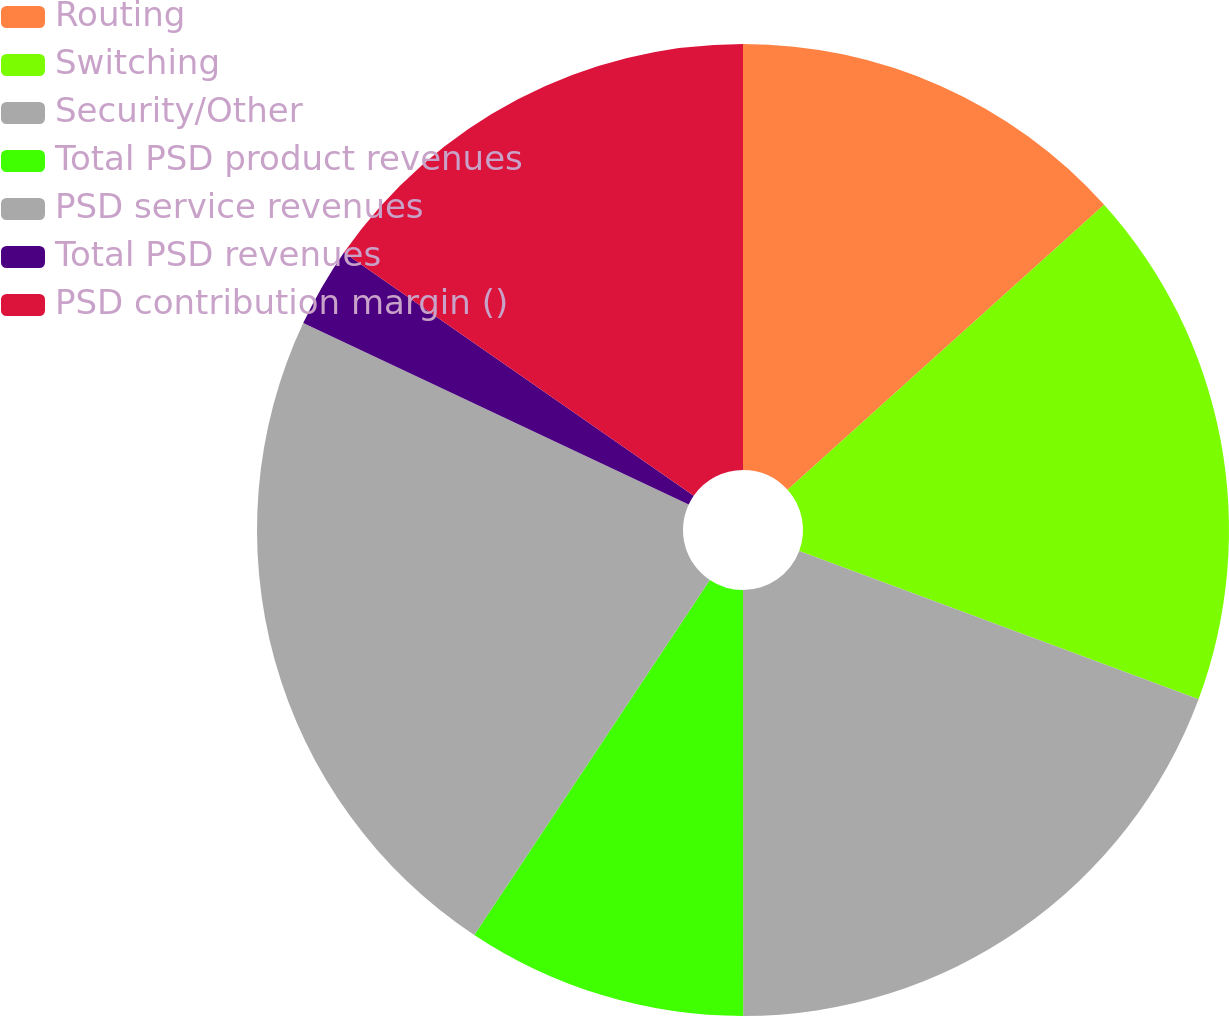Convert chart to OTSL. <chart><loc_0><loc_0><loc_500><loc_500><pie_chart><fcel>Routing<fcel>Switching<fcel>Security/Other<fcel>Total PSD product revenues<fcel>PSD service revenues<fcel>Total PSD revenues<fcel>PSD contribution margin ()<nl><fcel>13.33%<fcel>17.33%<fcel>19.33%<fcel>9.33%<fcel>22.67%<fcel>2.67%<fcel>15.33%<nl></chart> 